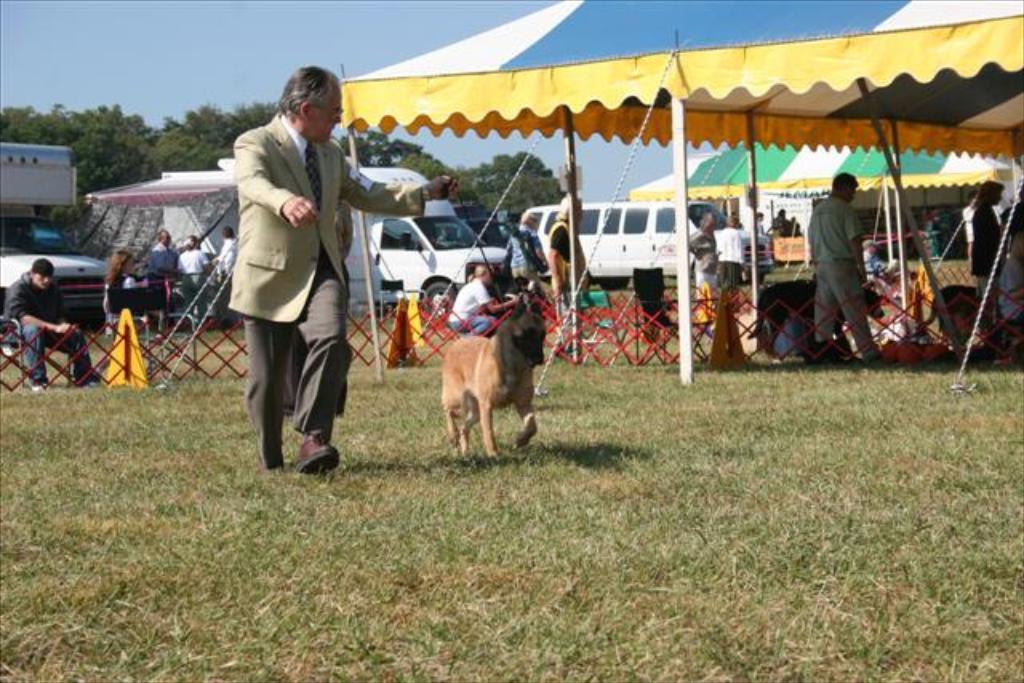How would you summarize this image in a sentence or two? In the image we can see there is a man who is standing with a dog and at the back people are sitting and standing and cars are parked on the ground. The ground is filled with grass. 